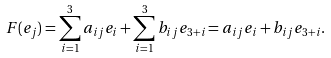<formula> <loc_0><loc_0><loc_500><loc_500>F ( e _ { j } ) = \sum _ { i = 1 } ^ { 3 } a _ { i j } e _ { i } + \sum _ { i = 1 } ^ { 3 } b _ { i j } e _ { 3 + i } = a _ { i j } e _ { i } + b _ { i j } e _ { 3 + i } .</formula> 